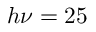<formula> <loc_0><loc_0><loc_500><loc_500>h \nu = 2 5</formula> 